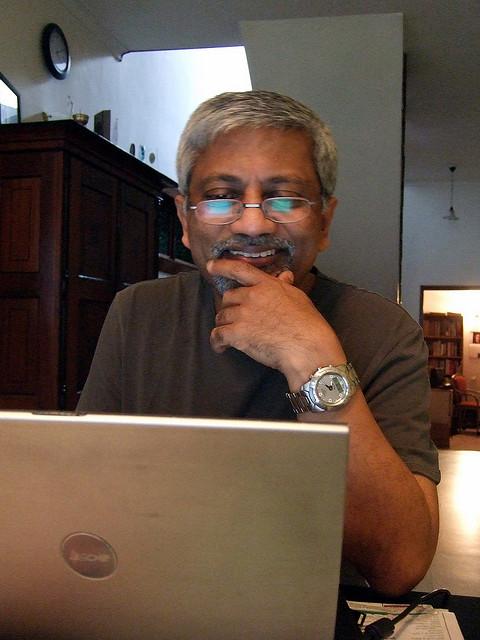Does his shirt have long sleeves?
Be succinct. No. What brand is the laptop?
Short answer required. Dell. Can the man tell the time?
Write a very short answer. Yes. 